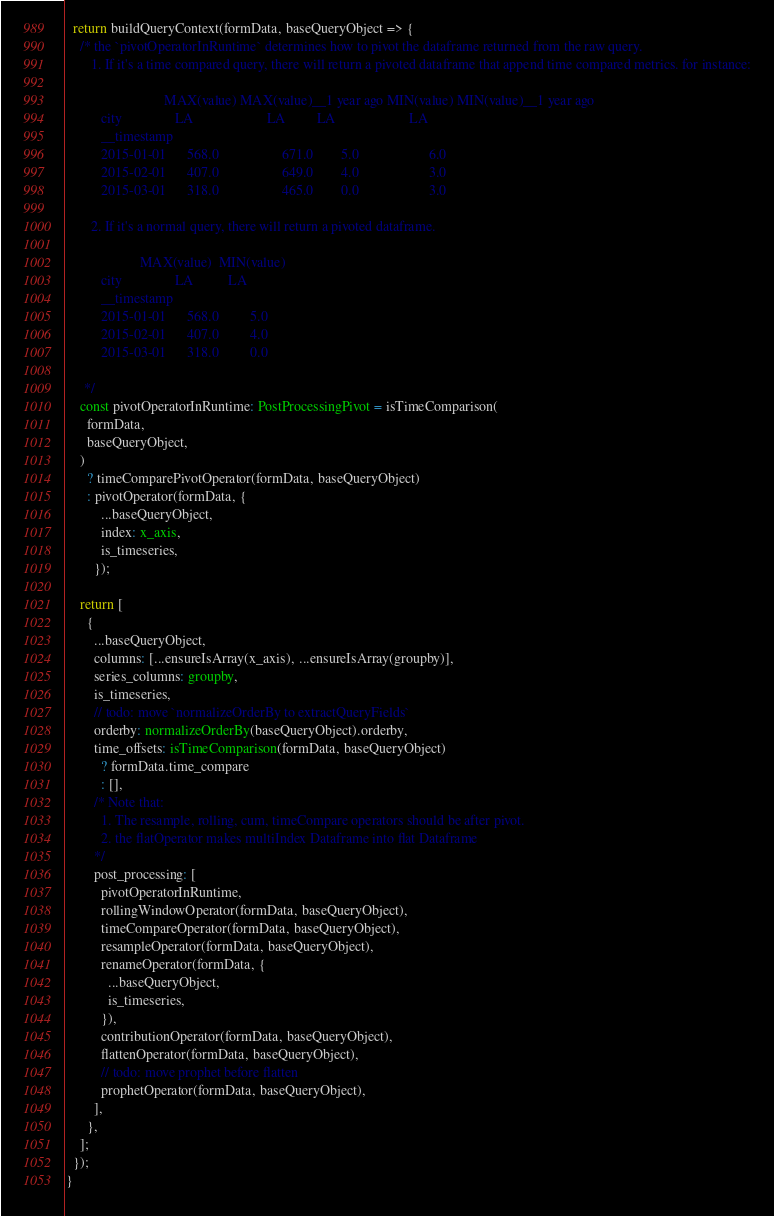<code> <loc_0><loc_0><loc_500><loc_500><_TypeScript_>  return buildQueryContext(formData, baseQueryObject => {
    /* the `pivotOperatorInRuntime` determines how to pivot the dataframe returned from the raw query.
       1. If it's a time compared query, there will return a pivoted dataframe that append time compared metrics. for instance:

                            MAX(value) MAX(value)__1 year ago MIN(value) MIN(value)__1 year ago
          city               LA                     LA         LA                     LA
          __timestamp
          2015-01-01      568.0                  671.0        5.0                    6.0
          2015-02-01      407.0                  649.0        4.0                    3.0
          2015-03-01      318.0                  465.0        0.0                    3.0

       2. If it's a normal query, there will return a pivoted dataframe.

                     MAX(value)  MIN(value)
          city               LA          LA
          __timestamp
          2015-01-01      568.0         5.0
          2015-02-01      407.0         4.0
          2015-03-01      318.0         0.0

     */
    const pivotOperatorInRuntime: PostProcessingPivot = isTimeComparison(
      formData,
      baseQueryObject,
    )
      ? timeComparePivotOperator(formData, baseQueryObject)
      : pivotOperator(formData, {
          ...baseQueryObject,
          index: x_axis,
          is_timeseries,
        });

    return [
      {
        ...baseQueryObject,
        columns: [...ensureIsArray(x_axis), ...ensureIsArray(groupby)],
        series_columns: groupby,
        is_timeseries,
        // todo: move `normalizeOrderBy to extractQueryFields`
        orderby: normalizeOrderBy(baseQueryObject).orderby,
        time_offsets: isTimeComparison(formData, baseQueryObject)
          ? formData.time_compare
          : [],
        /* Note that:
          1. The resample, rolling, cum, timeCompare operators should be after pivot.
          2. the flatOperator makes multiIndex Dataframe into flat Dataframe
        */
        post_processing: [
          pivotOperatorInRuntime,
          rollingWindowOperator(formData, baseQueryObject),
          timeCompareOperator(formData, baseQueryObject),
          resampleOperator(formData, baseQueryObject),
          renameOperator(formData, {
            ...baseQueryObject,
            is_timeseries,
          }),
          contributionOperator(formData, baseQueryObject),
          flattenOperator(formData, baseQueryObject),
          // todo: move prophet before flatten
          prophetOperator(formData, baseQueryObject),
        ],
      },
    ];
  });
}
</code> 